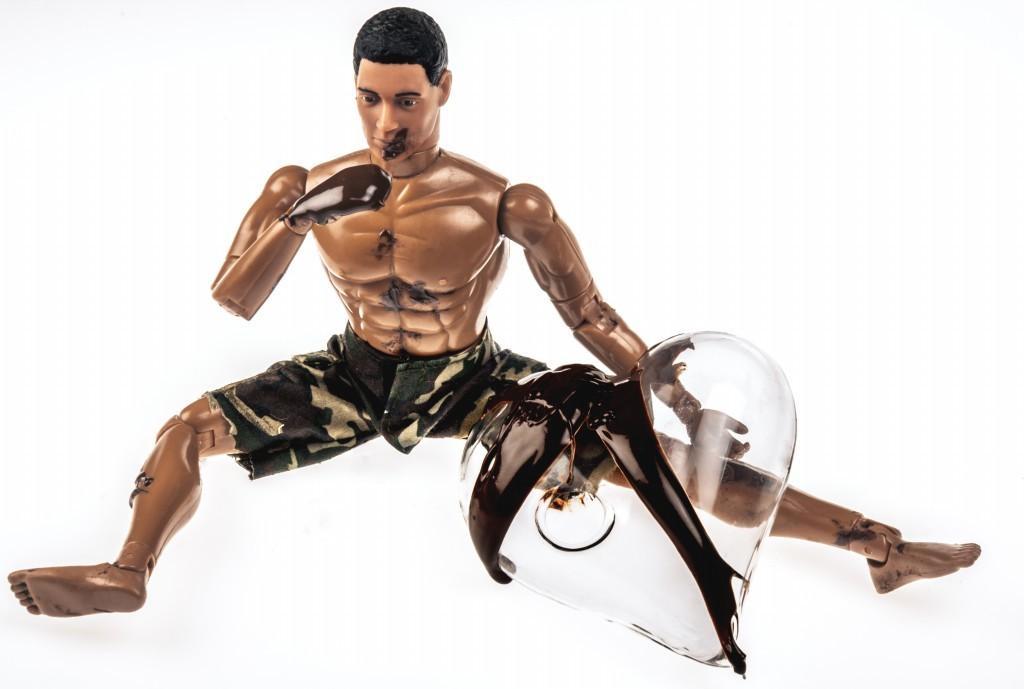Can you describe this image briefly? In this image in the front there is a robot. 